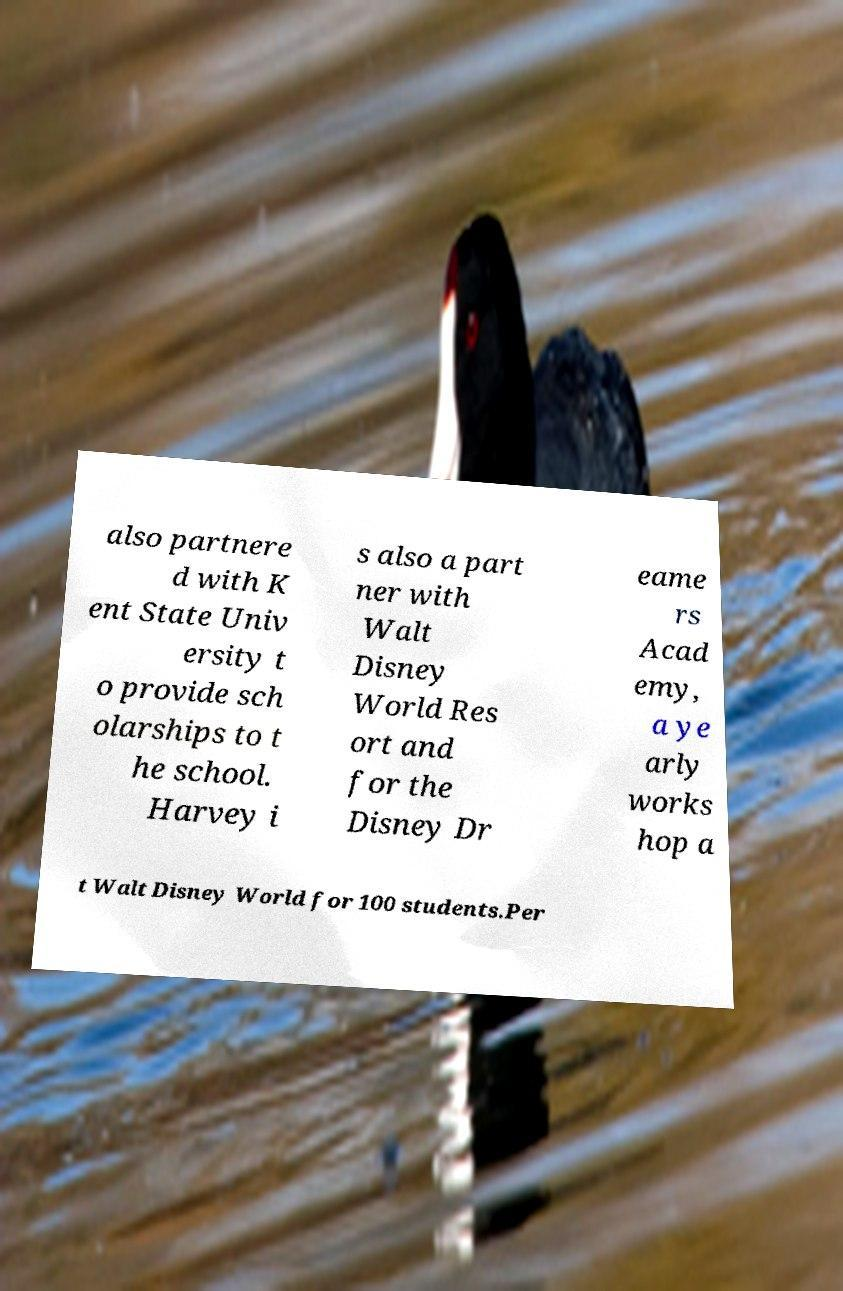Could you extract and type out the text from this image? also partnere d with K ent State Univ ersity t o provide sch olarships to t he school. Harvey i s also a part ner with Walt Disney World Res ort and for the Disney Dr eame rs Acad emy, a ye arly works hop a t Walt Disney World for 100 students.Per 